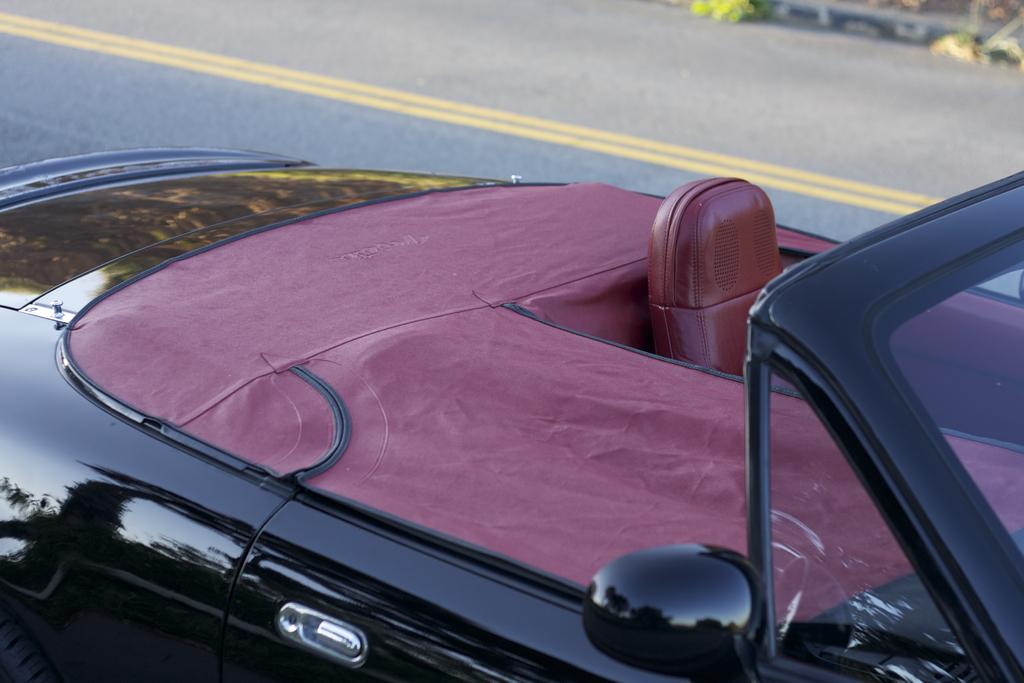What is the main subject of the image? The main subject of the image is a car. Where is the car located in the image? The car is on the road. How many ducks can be seen in the image? There are no ducks present in the image; it features a car on the road. What effect does the car have on the environment in the image? The provided facts do not mention any environmental effects of the car in the image. 